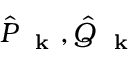<formula> <loc_0><loc_0><loc_500><loc_500>\hat { P } _ { k } , \hat { Q } _ { k }</formula> 